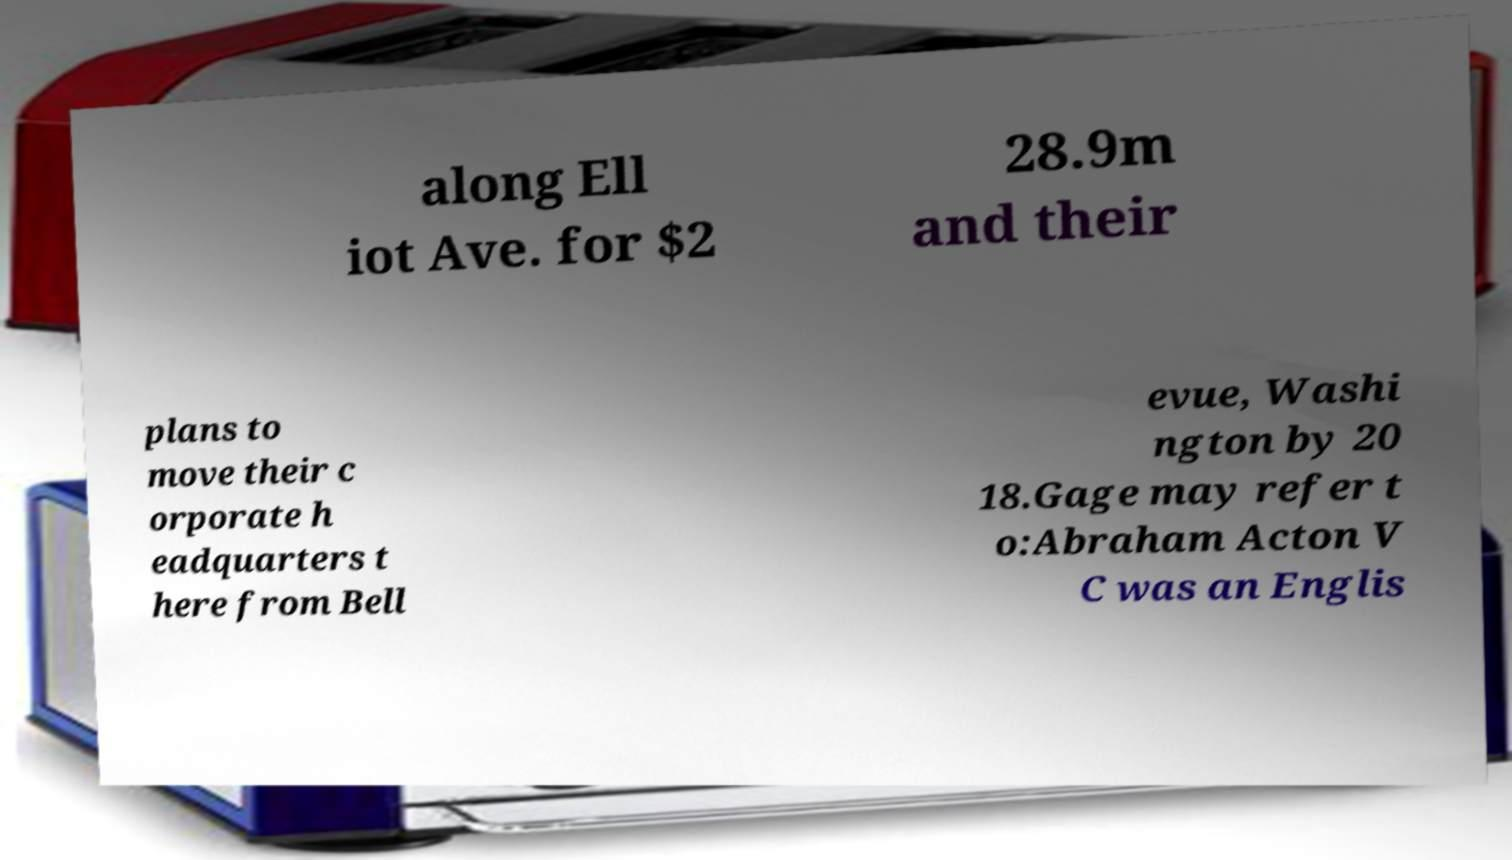Can you accurately transcribe the text from the provided image for me? along Ell iot Ave. for $2 28.9m and their plans to move their c orporate h eadquarters t here from Bell evue, Washi ngton by 20 18.Gage may refer t o:Abraham Acton V C was an Englis 